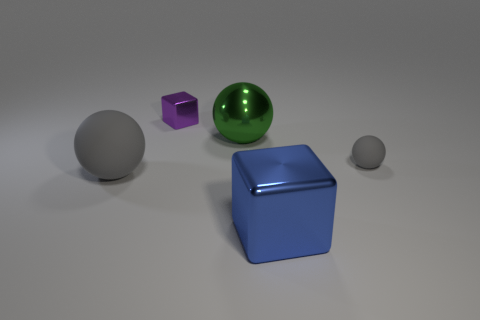What is the material of the blue block that is the same size as the green ball?
Your answer should be very brief. Metal. Does the gray thing that is to the left of the small purple object have the same size as the cube left of the big green object?
Your response must be concise. No. How many things are either cyan matte spheres or gray objects that are to the right of the small purple cube?
Provide a succinct answer. 1. Is there a large green matte thing that has the same shape as the tiny purple thing?
Your answer should be compact. No. There is a gray object to the right of the shiny block that is behind the blue block; what size is it?
Offer a very short reply. Small. Does the small cube have the same color as the big block?
Give a very brief answer. No. What number of metallic things are either small gray objects or tiny purple blocks?
Ensure brevity in your answer.  1. What number of big metallic objects are there?
Offer a terse response. 2. Is the gray object behind the big gray ball made of the same material as the gray thing left of the large cube?
Your response must be concise. Yes. There is another big metal object that is the same shape as the purple metallic thing; what is its color?
Keep it short and to the point. Blue. 